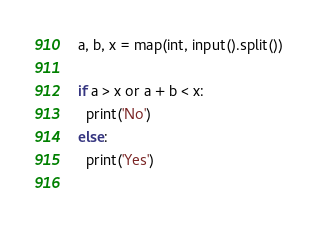Convert code to text. <code><loc_0><loc_0><loc_500><loc_500><_Python_>a, b, x = map(int, input().split())

if a > x or a + b < x:
  print('No')
else:
  print('Yes')
  </code> 